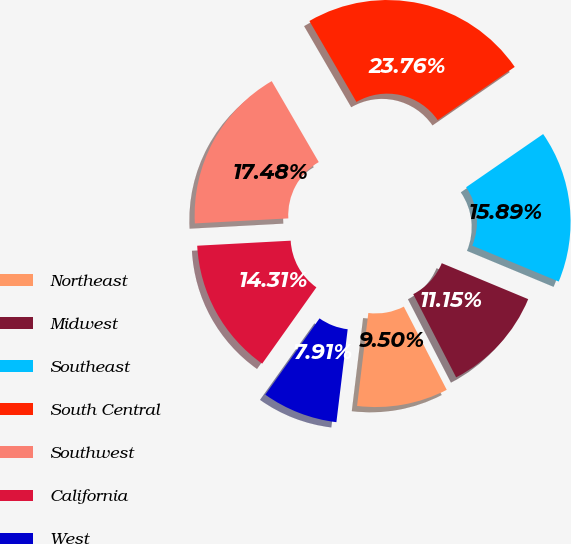Convert chart to OTSL. <chart><loc_0><loc_0><loc_500><loc_500><pie_chart><fcel>Northeast<fcel>Midwest<fcel>Southeast<fcel>South Central<fcel>Southwest<fcel>California<fcel>West<nl><fcel>9.5%<fcel>11.15%<fcel>15.89%<fcel>23.76%<fcel>17.48%<fcel>14.31%<fcel>7.91%<nl></chart> 